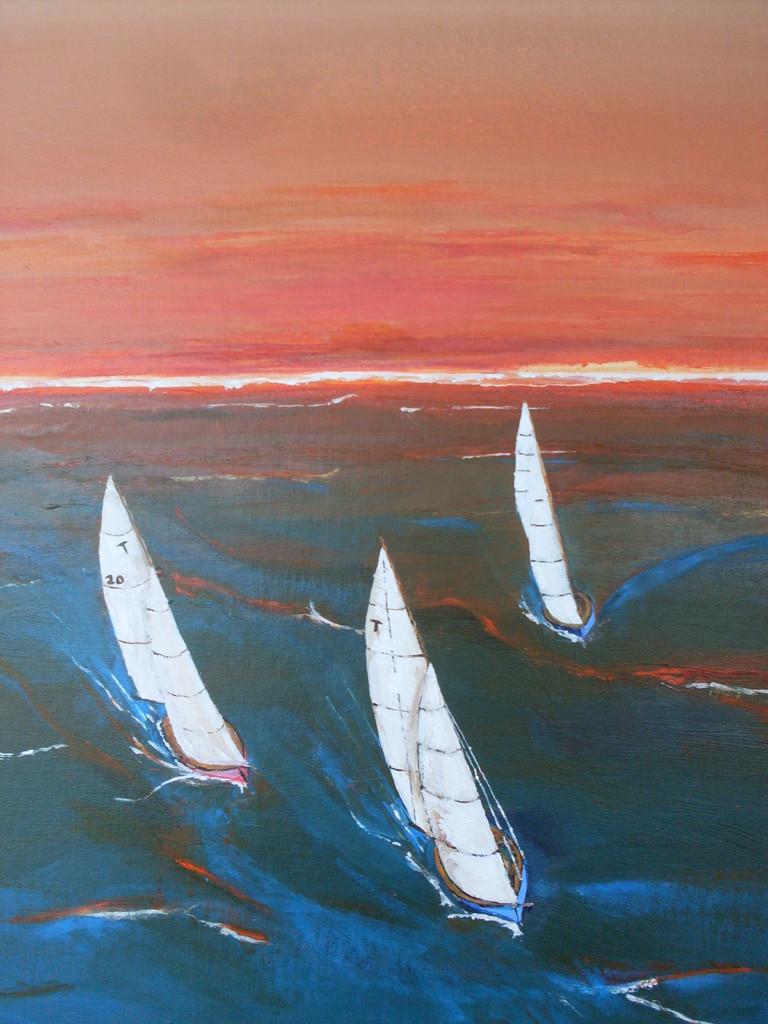What letter is on two of the sailboats?
Offer a very short reply. T. 